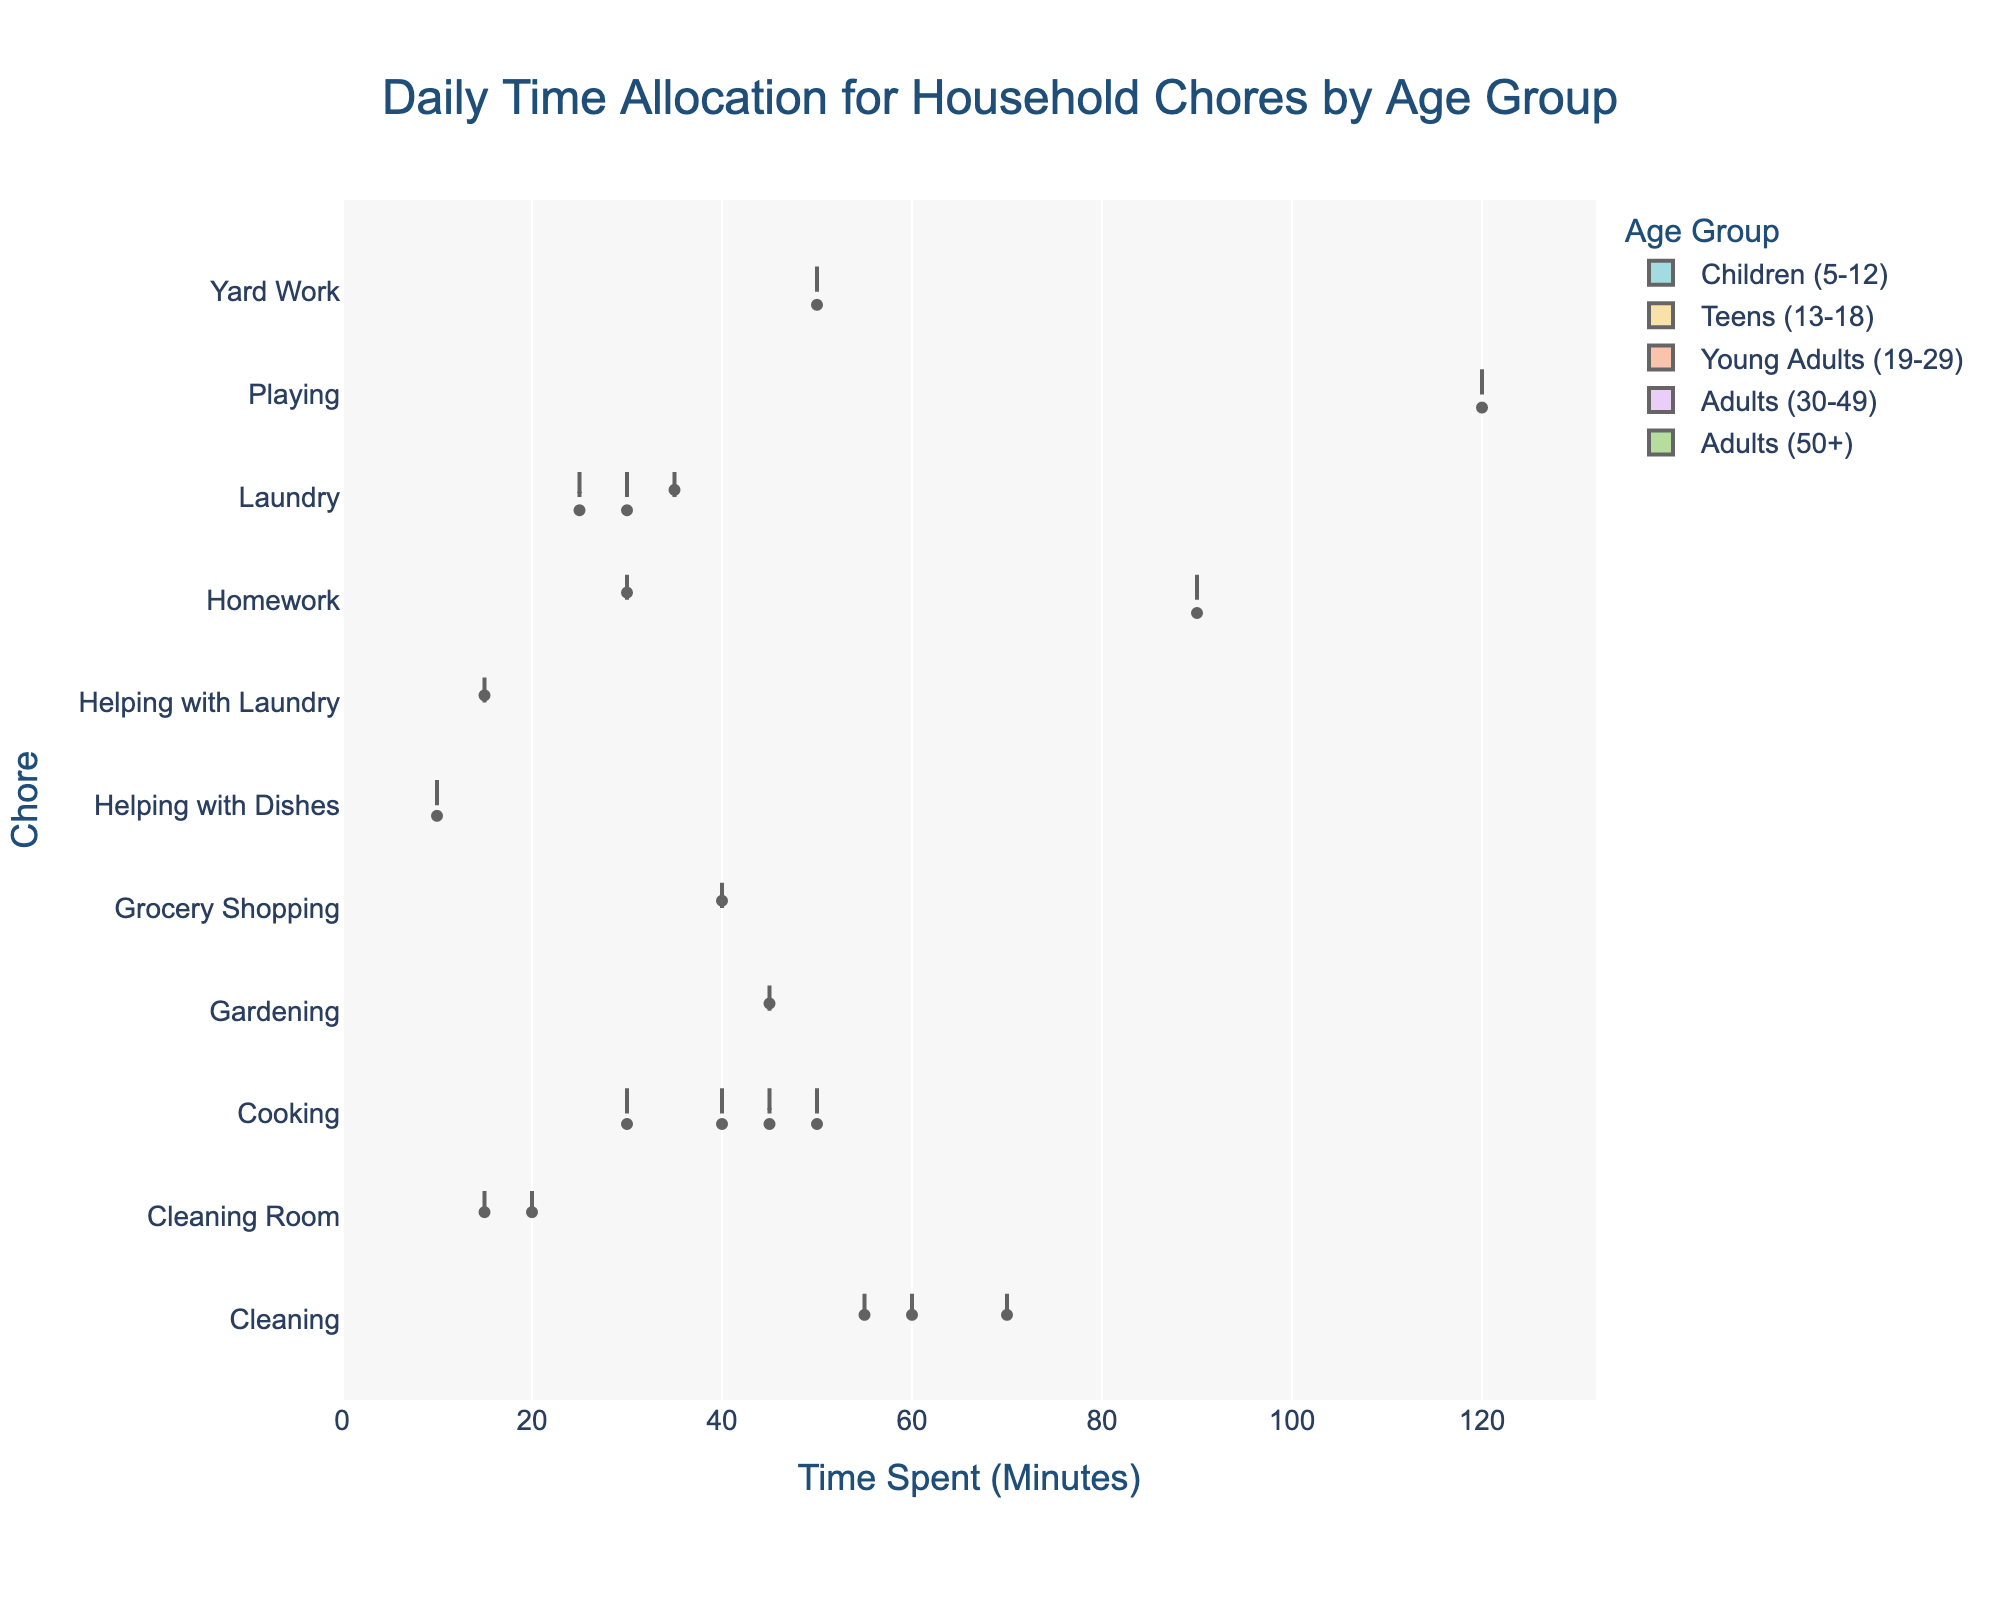What is the title of the plot? The title of the plot is located at the top and provides a clear description of what the chart is about. Reading the title tells us the figure shows how different age groups spend their time on household chores.
Answer: Daily Time Allocation for Household Chores by Age Group Which age group spends the most time on cleaning? To determine which age group spends the most time on cleaning, look at the cleaning-related entries for each age group and compare the values. Adults (30-49) have the highest mean time spent on cleaning at 70 minutes.
Answer: Adults (30-49) What is the median time spent on cooking for Adults (30-49)? The violin plot for Adults (30-49) and the chore 'Cooking' includes a box plot that displays the median as a horizontal line within the box. This median line can be read directly from the plot.
Answer: 50 minutes How does the average time spent on laundry compare between Young Adults (19-29) and Adults (50+)? To compare averages, note the mean lines or box plots within each respective violin plot for laundry for the age groups in question. Young Adults (19-29) spend an average of approximately 30 minutes, while Adults (50+) spend around 25 minutes.
Answer: Young Adults (19-29) spend more time Which chore has the most varied time allocation among Teens (13-18)? Variance is indicated by the width of the violin plots. For Teens (13-18), the homework chore has the widest distribution, indicating the most varied time allocation.
Answer: Homework Which age group has the smallest range in time spent on cooking? The range can be evaluated by looking at the spread of the data points or the width of the box plot within the violin plot for the cooking chore. Adults (50+) have the smallest range, showing less variability in time spent.
Answer: Adults (50+) Are there any chores that only one age group spends time on? We need to identify if any chores are unique to a single age group. 'Playing' for Children (5-12) is an example, given it's listed only for this group.
Answer: Playing (Children, 5-12) For which chore and age group is the mean time spent closest to the overall maximum time spent among all chores and groups? First, identify the overall maximum time among all chores and age groups, which is 120 minutes (Playing for Children (5-12)). The mean time closest to this is observed visually in the plot for 'Playing' as well.
Answer: Playing (Children, 5-12) What is the range of time spent on yard work for Adults (30-49)? To find the range, look at the box plot within the violin for yard work for Adults (30-49). The range is calculated from the minimum to the maximum data points. The range approximates from 0 to 50 minutes.
Answer: 0 - 50 minutes 